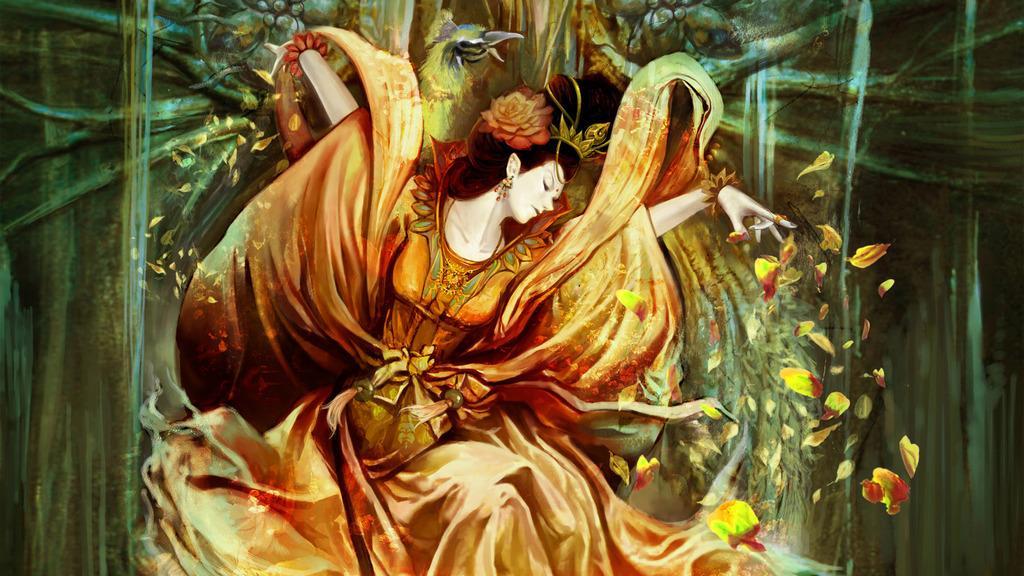Can you describe this image briefly? In this picture there is a drawing poster of the women wearing orange color dress. Behind there is a dry tree branches. 